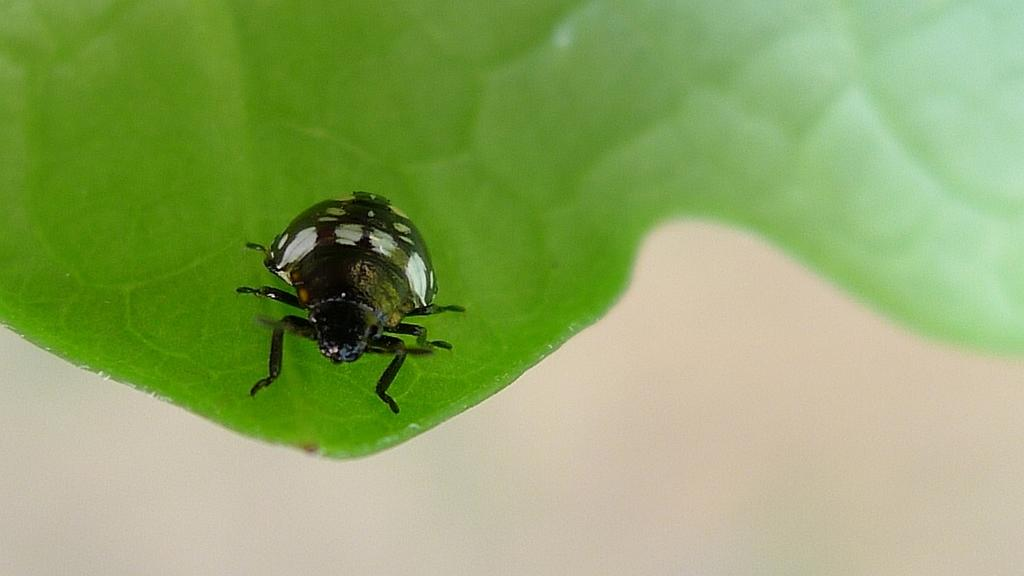What is present in the picture? There is an insect in the picture. What color is the insect? The insect is black in color. Where is the insect located? The insect is on a leaf. What color is the leaf? The leaf is green in color. Is there an airport visible in the picture? No, there is no airport present in the image. Is there any indication of a fight or conflict in the picture? No, there is no indication of a fight or conflict in the image. 